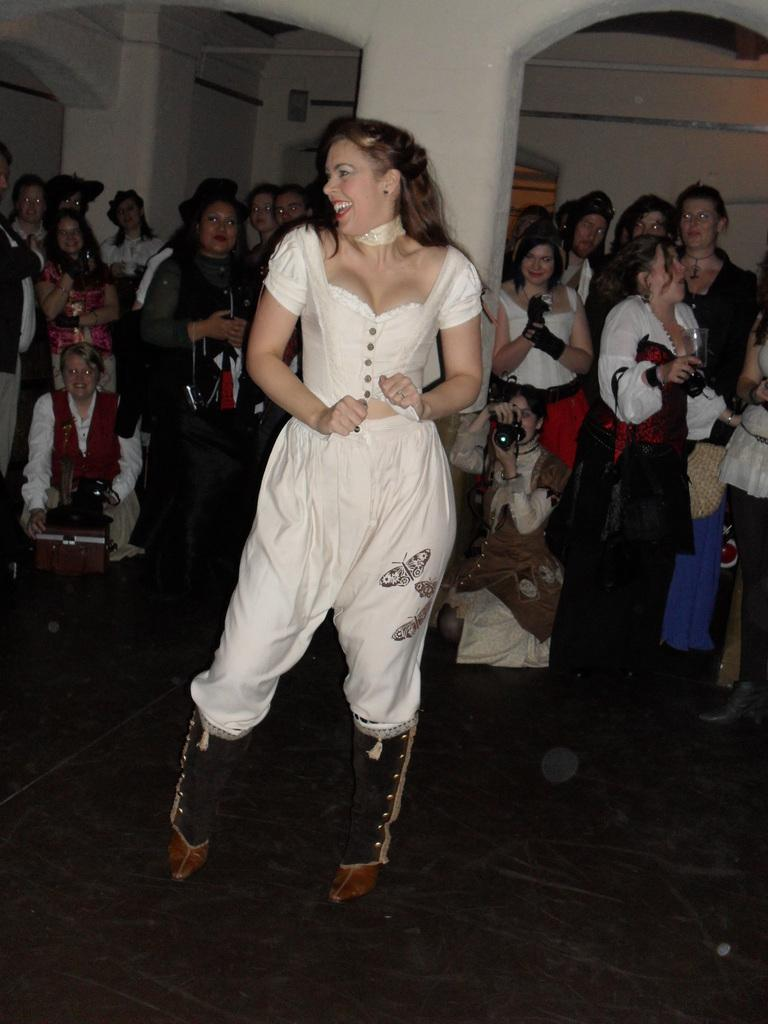How many people are in the image? There is a group of people in the image. What are the people wearing? The people are wearing clothes. Can you describe the position of the person in the middle of the image? The person is standing in the middle of the image. What is the person standing in front of? The person is standing in front of a pillar. What type of bear can be seen interacting with the group of people in the image? There is no bear present in the image; it features a group of people and a pillar. Can you describe the ghostly apparition that is haunting the group of people in the image? There is no ghostly apparition present in the image; it features a group of people and a pillar. 